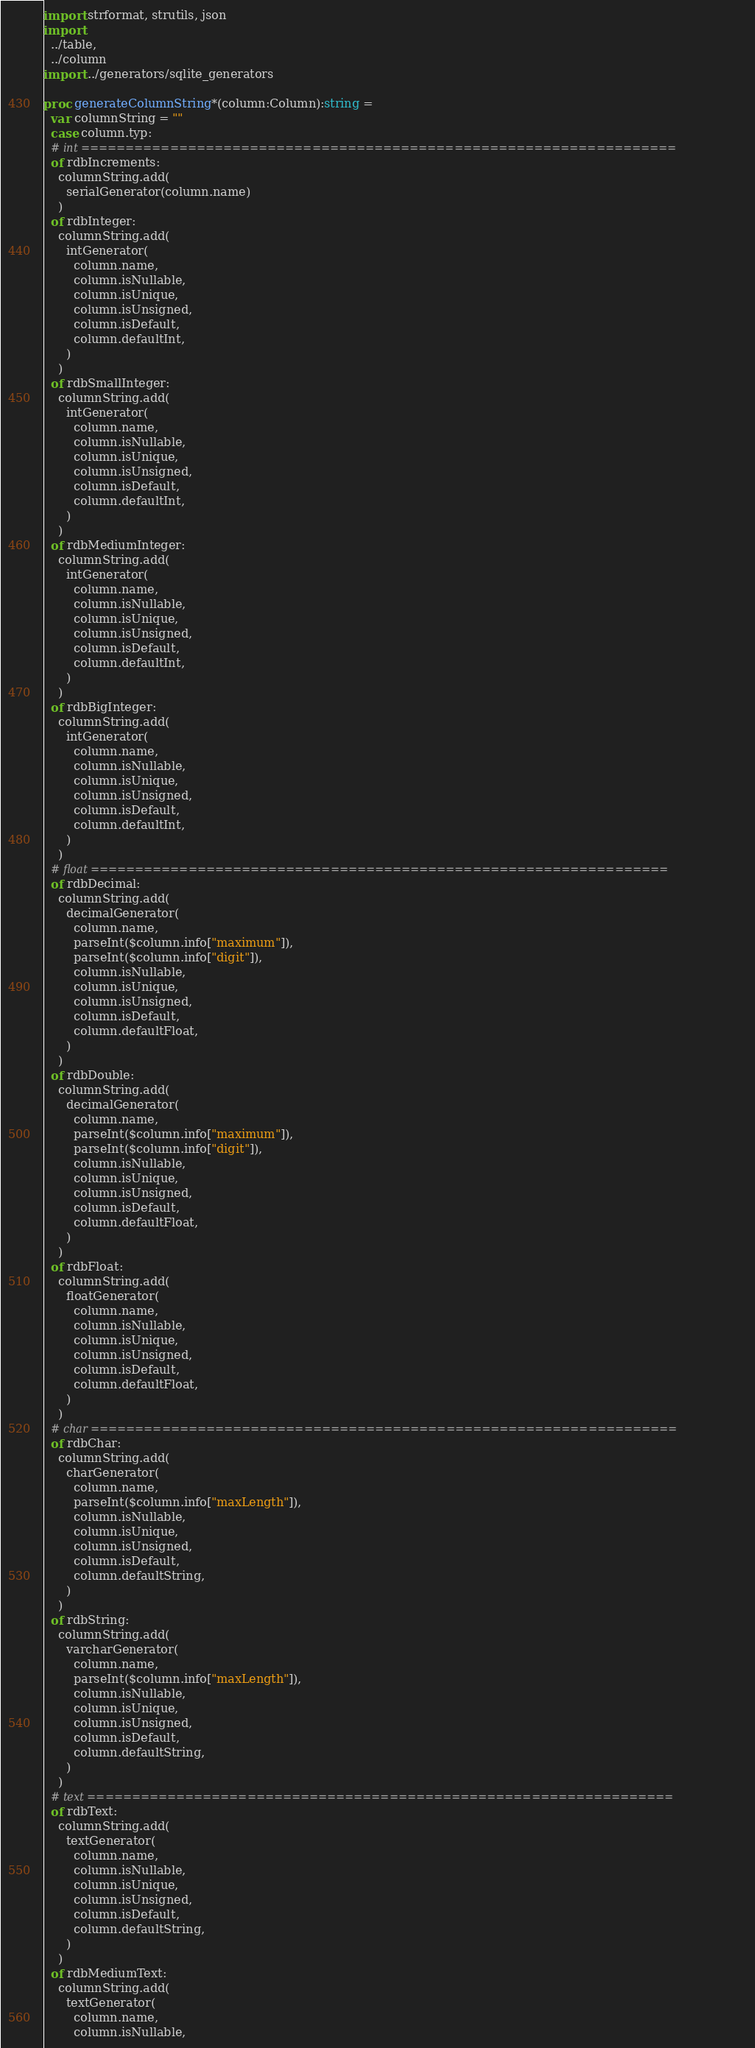<code> <loc_0><loc_0><loc_500><loc_500><_Nim_>import strformat, strutils, json
import
  ../table,
  ../column
import ../generators/sqlite_generators

proc generateColumnString*(column:Column):string =
  var columnString = ""
  case column.typ:
  # int ===================================================================
  of rdbIncrements:
    columnString.add(
      serialGenerator(column.name)
    )
  of rdbInteger:
    columnString.add(
      intGenerator(
        column.name,
        column.isNullable,
        column.isUnique,
        column.isUnsigned,
        column.isDefault,
        column.defaultInt,
      )
    )
  of rdbSmallInteger:
    columnString.add(
      intGenerator(
        column.name,
        column.isNullable,
        column.isUnique,
        column.isUnsigned,
        column.isDefault,
        column.defaultInt,
      )
    )
  of rdbMediumInteger:
    columnString.add(
      intGenerator(
        column.name,
        column.isNullable,
        column.isUnique,
        column.isUnsigned,
        column.isDefault,
        column.defaultInt,
      )
    )
  of rdbBigInteger:
    columnString.add(
      intGenerator(
        column.name,
        column.isNullable,
        column.isUnique,
        column.isUnsigned,
        column.isDefault,
        column.defaultInt,
      )
    )
  # float =================================================================
  of rdbDecimal:
    columnString.add(
      decimalGenerator(
        column.name,
        parseInt($column.info["maximum"]),
        parseInt($column.info["digit"]),
        column.isNullable,
        column.isUnique,
        column.isUnsigned,
        column.isDefault,
        column.defaultFloat,
      )
    )
  of rdbDouble:
    columnString.add(
      decimalGenerator(
        column.name,
        parseInt($column.info["maximum"]),
        parseInt($column.info["digit"]),
        column.isNullable,
        column.isUnique,
        column.isUnsigned,
        column.isDefault,
        column.defaultFloat,
      )
    )
  of rdbFloat:
    columnString.add(
      floatGenerator(
        column.name,
        column.isNullable,
        column.isUnique,
        column.isUnsigned,
        column.isDefault,
        column.defaultFloat,
      )
    )
  # char ==================================================================
  of rdbChar:
    columnString.add(
      charGenerator(
        column.name,
        parseInt($column.info["maxLength"]),
        column.isNullable,
        column.isUnique,
        column.isUnsigned,
        column.isDefault,
        column.defaultString,
      )
    )
  of rdbString:
    columnString.add(
      varcharGenerator(
        column.name,
        parseInt($column.info["maxLength"]),
        column.isNullable,
        column.isUnique,
        column.isUnsigned,
        column.isDefault,
        column.defaultString,
      )
    )
  # text ==================================================================
  of rdbText:
    columnString.add(
      textGenerator(
        column.name,
        column.isNullable,
        column.isUnique,
        column.isUnsigned,
        column.isDefault,
        column.defaultString,
      )
    )
  of rdbMediumText:
    columnString.add(
      textGenerator(
        column.name,
        column.isNullable,</code> 